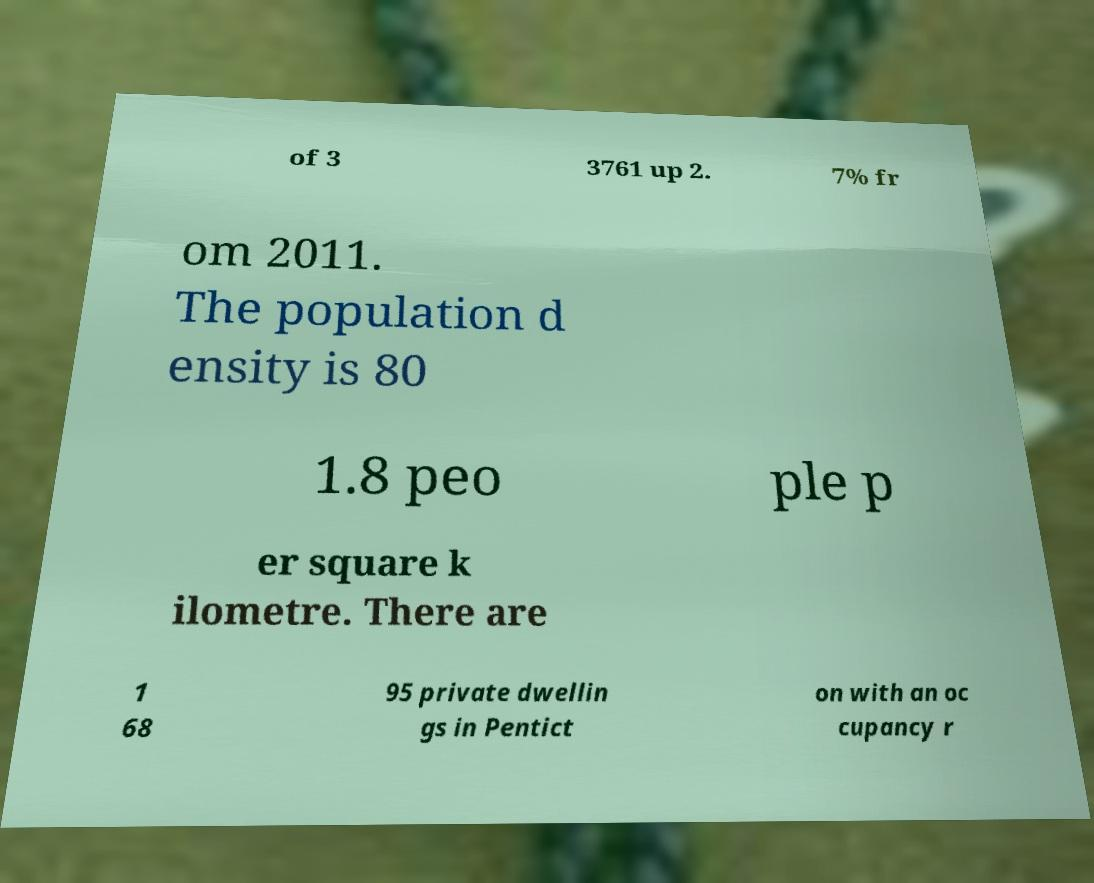There's text embedded in this image that I need extracted. Can you transcribe it verbatim? of 3 3761 up 2. 7% fr om 2011. The population d ensity is 80 1.8 peo ple p er square k ilometre. There are 1 68 95 private dwellin gs in Pentict on with an oc cupancy r 